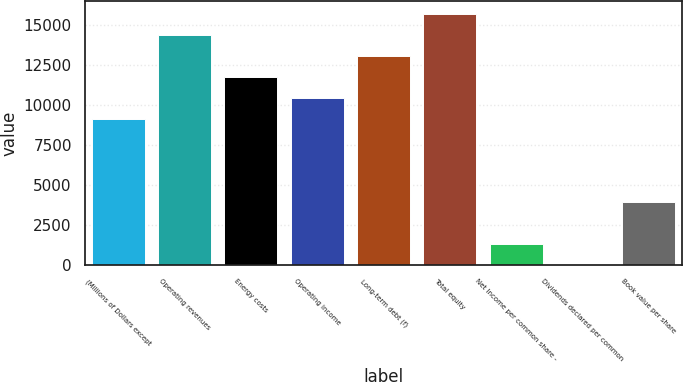Convert chart. <chart><loc_0><loc_0><loc_500><loc_500><bar_chart><fcel>(Millions of Dollars except<fcel>Operating revenues<fcel>Energy costs<fcel>Operating income<fcel>Long-term debt (f)<fcel>Total equity<fcel>Net Income per common share -<fcel>Dividends declared per common<fcel>Book value per share<nl><fcel>9143.48<fcel>14366.8<fcel>11755.2<fcel>10449.3<fcel>13061<fcel>15672.7<fcel>1308.44<fcel>2.6<fcel>3920.12<nl></chart> 